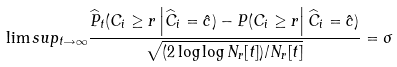Convert formula to latex. <formula><loc_0><loc_0><loc_500><loc_500>\lim s u p _ { t \rightarrow \infty } \frac { \widehat { P } _ { t } ( C _ { i } \geq r \left | \widehat { C } _ { i } = \hat { c } ) - P ( C _ { i } \geq r \right | \widehat { C } _ { i } = \hat { c } ) } { \sqrt { ( 2 \log \log N _ { r } [ t ] ) / N _ { r } [ t ] } } = \sigma</formula> 